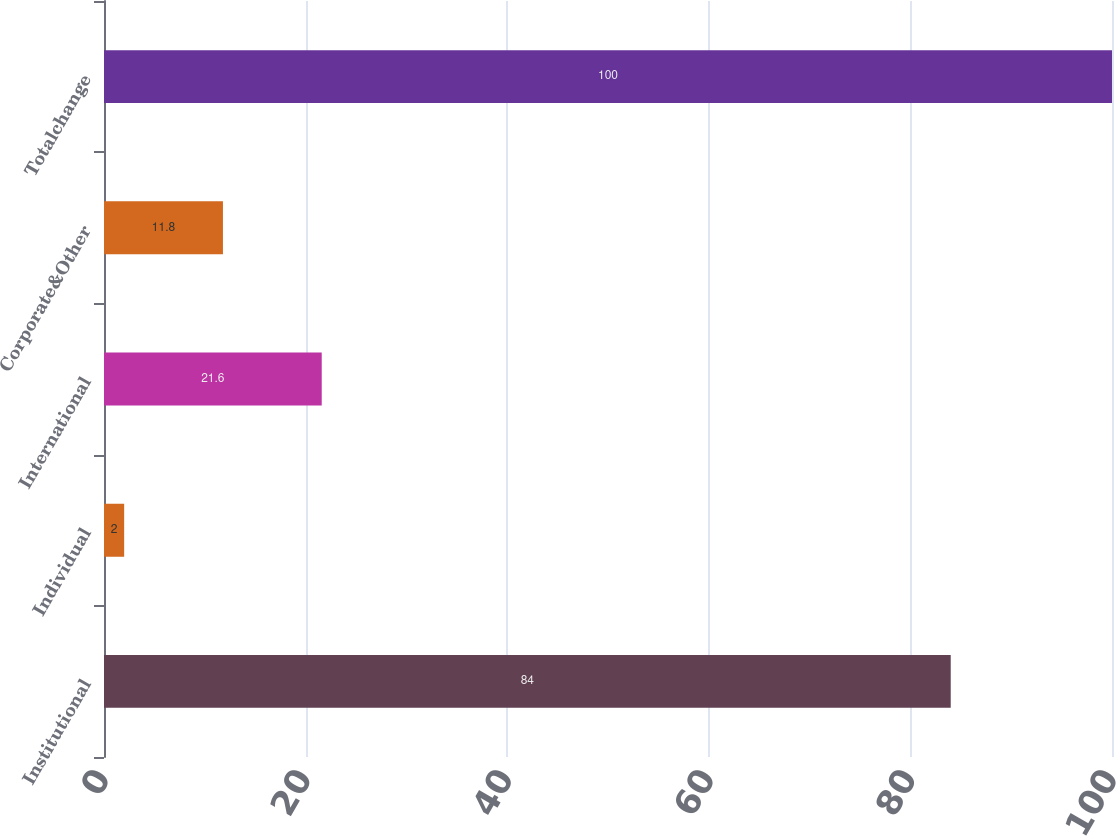<chart> <loc_0><loc_0><loc_500><loc_500><bar_chart><fcel>Institutional<fcel>Individual<fcel>International<fcel>Corporate&Other<fcel>Totalchange<nl><fcel>84<fcel>2<fcel>21.6<fcel>11.8<fcel>100<nl></chart> 